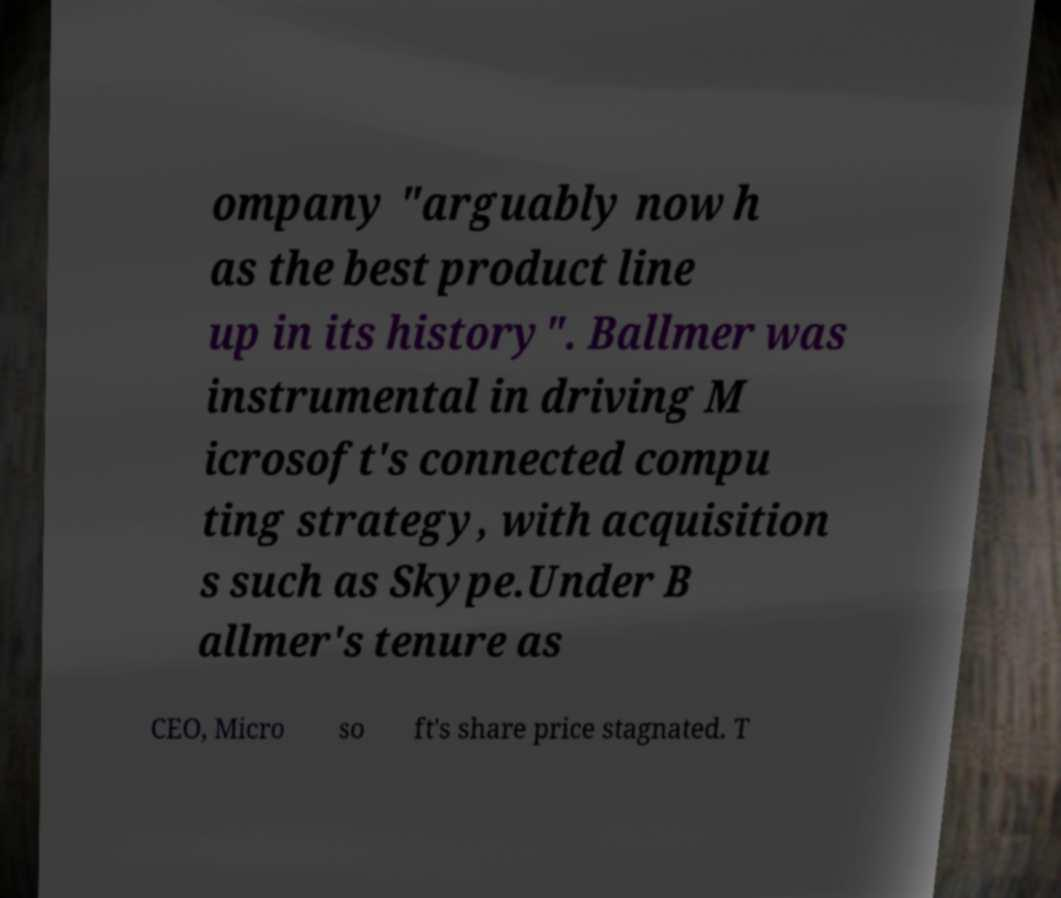Can you read and provide the text displayed in the image?This photo seems to have some interesting text. Can you extract and type it out for me? ompany "arguably now h as the best product line up in its history". Ballmer was instrumental in driving M icrosoft's connected compu ting strategy, with acquisition s such as Skype.Under B allmer's tenure as CEO, Micro so ft's share price stagnated. T 